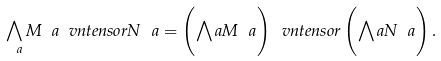<formula> <loc_0><loc_0><loc_500><loc_500>\bigwedge _ { \ a } M _ { \ } a \ v n t e n s o r N _ { \ } a = \left ( \bigwedge _ { \ } a M _ { \ } a \right ) \ v n t e n s o r \left ( \bigwedge _ { \ } a N _ { \ } a \right ) .</formula> 